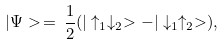<formula> <loc_0><loc_0><loc_500><loc_500>| \Psi > \, = \, \frac { 1 } { 2 } ( | \uparrow _ { 1 } \downarrow _ { 2 } > - | \downarrow _ { 1 } \uparrow _ { 2 } > ) ,</formula> 